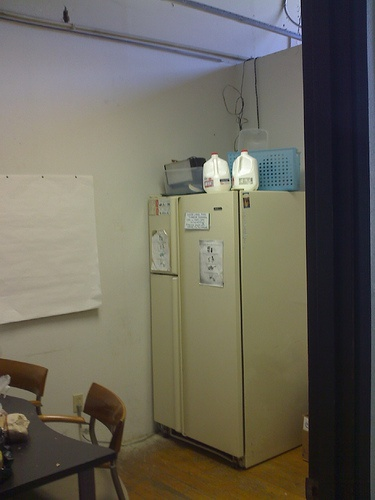Describe the objects in this image and their specific colors. I can see refrigerator in gray, olive, and darkgray tones, dining table in gray and black tones, chair in gray, black, and maroon tones, and chair in gray, black, and maroon tones in this image. 